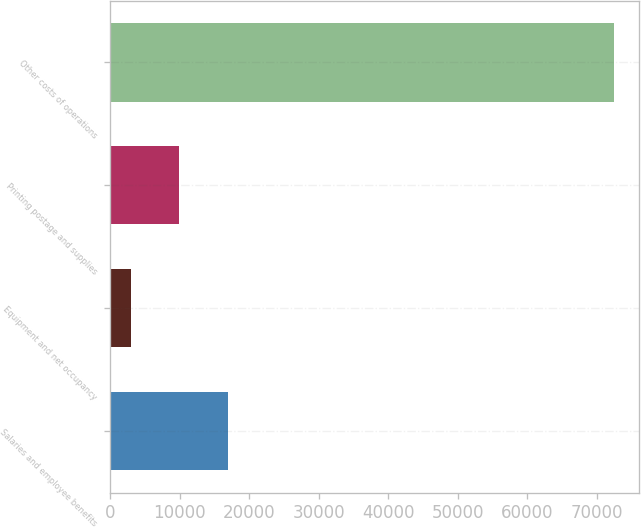Convert chart. <chart><loc_0><loc_0><loc_500><loc_500><bar_chart><fcel>Salaries and employee benefits<fcel>Equipment and net occupancy<fcel>Printing postage and supplies<fcel>Other costs of operations<nl><fcel>16875<fcel>2975<fcel>9925<fcel>72475<nl></chart> 